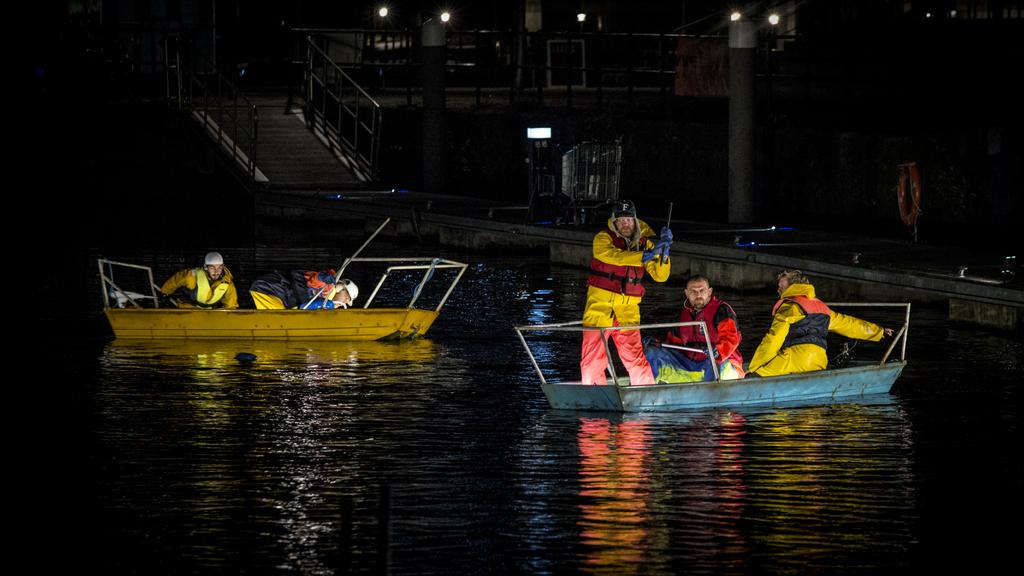What are the people in the image doing? The people in the image are in boats. What type of structures can be seen in the image? There are metal rods visible in the image. What can be seen illuminated in the image? There are lights in the image. What is the primary setting of the image? There is water visible in the image. How many pigs are floating on the water in the image? There are no pigs present in the image; it features people in boats and other elements. 